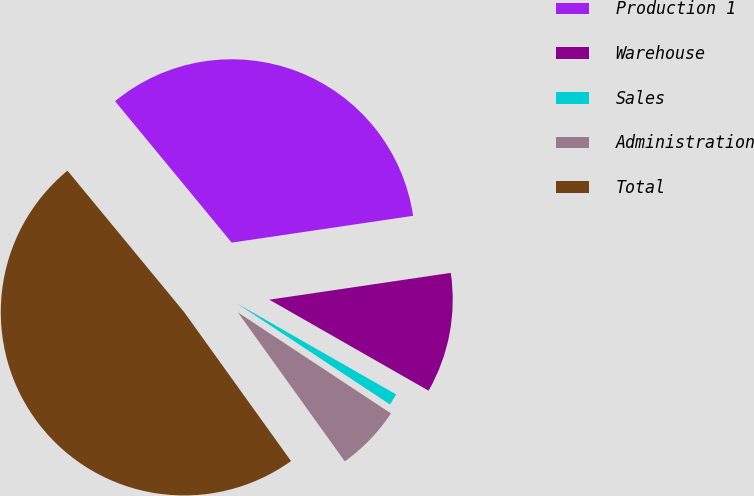Convert chart to OTSL. <chart><loc_0><loc_0><loc_500><loc_500><pie_chart><fcel>Production 1<fcel>Warehouse<fcel>Sales<fcel>Administration<fcel>Total<nl><fcel>33.64%<fcel>10.6%<fcel>1.02%<fcel>5.81%<fcel>48.93%<nl></chart> 